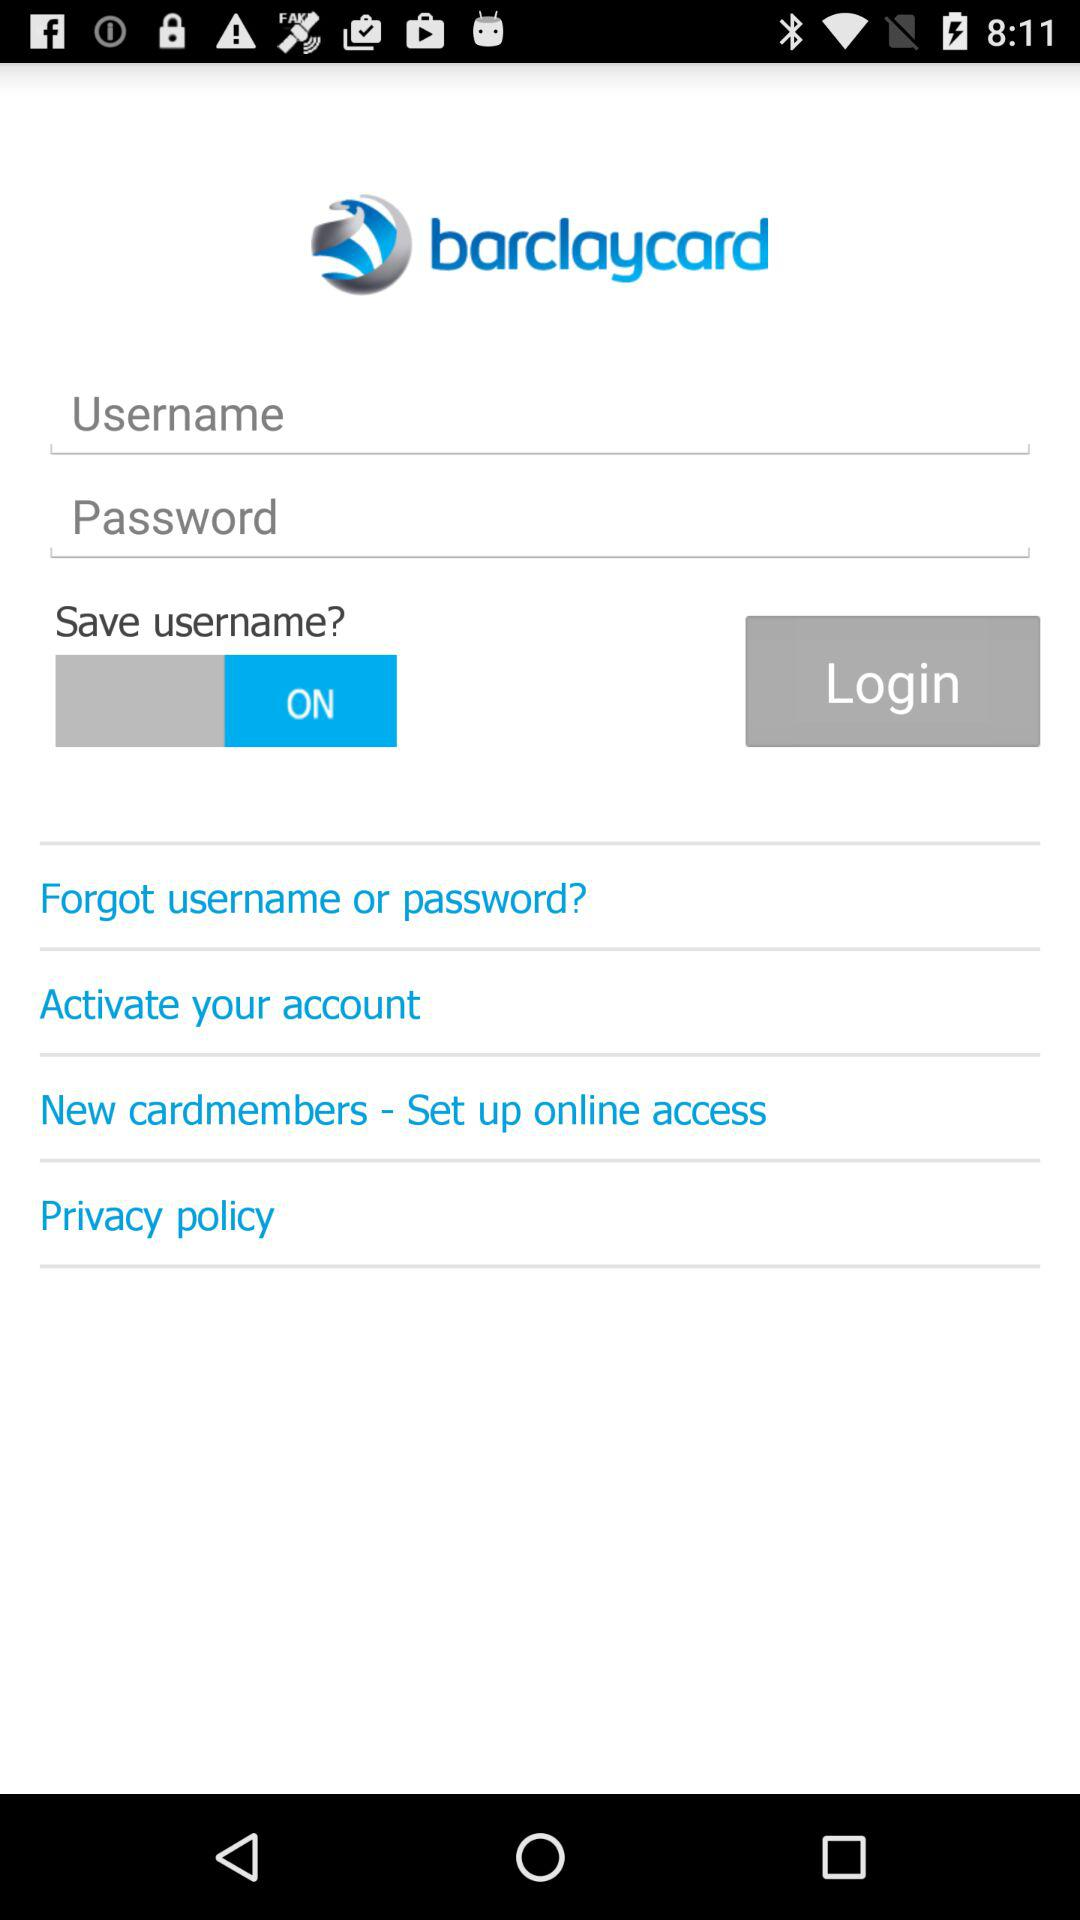What is the status of "Save username?"? The status is "on". 